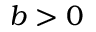<formula> <loc_0><loc_0><loc_500><loc_500>b > 0</formula> 